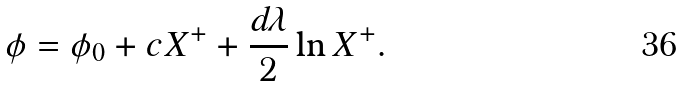Convert formula to latex. <formula><loc_0><loc_0><loc_500><loc_500>\phi = \phi _ { 0 } + c X ^ { + } + \frac { d \lambda } 2 \ln X ^ { + } .</formula> 